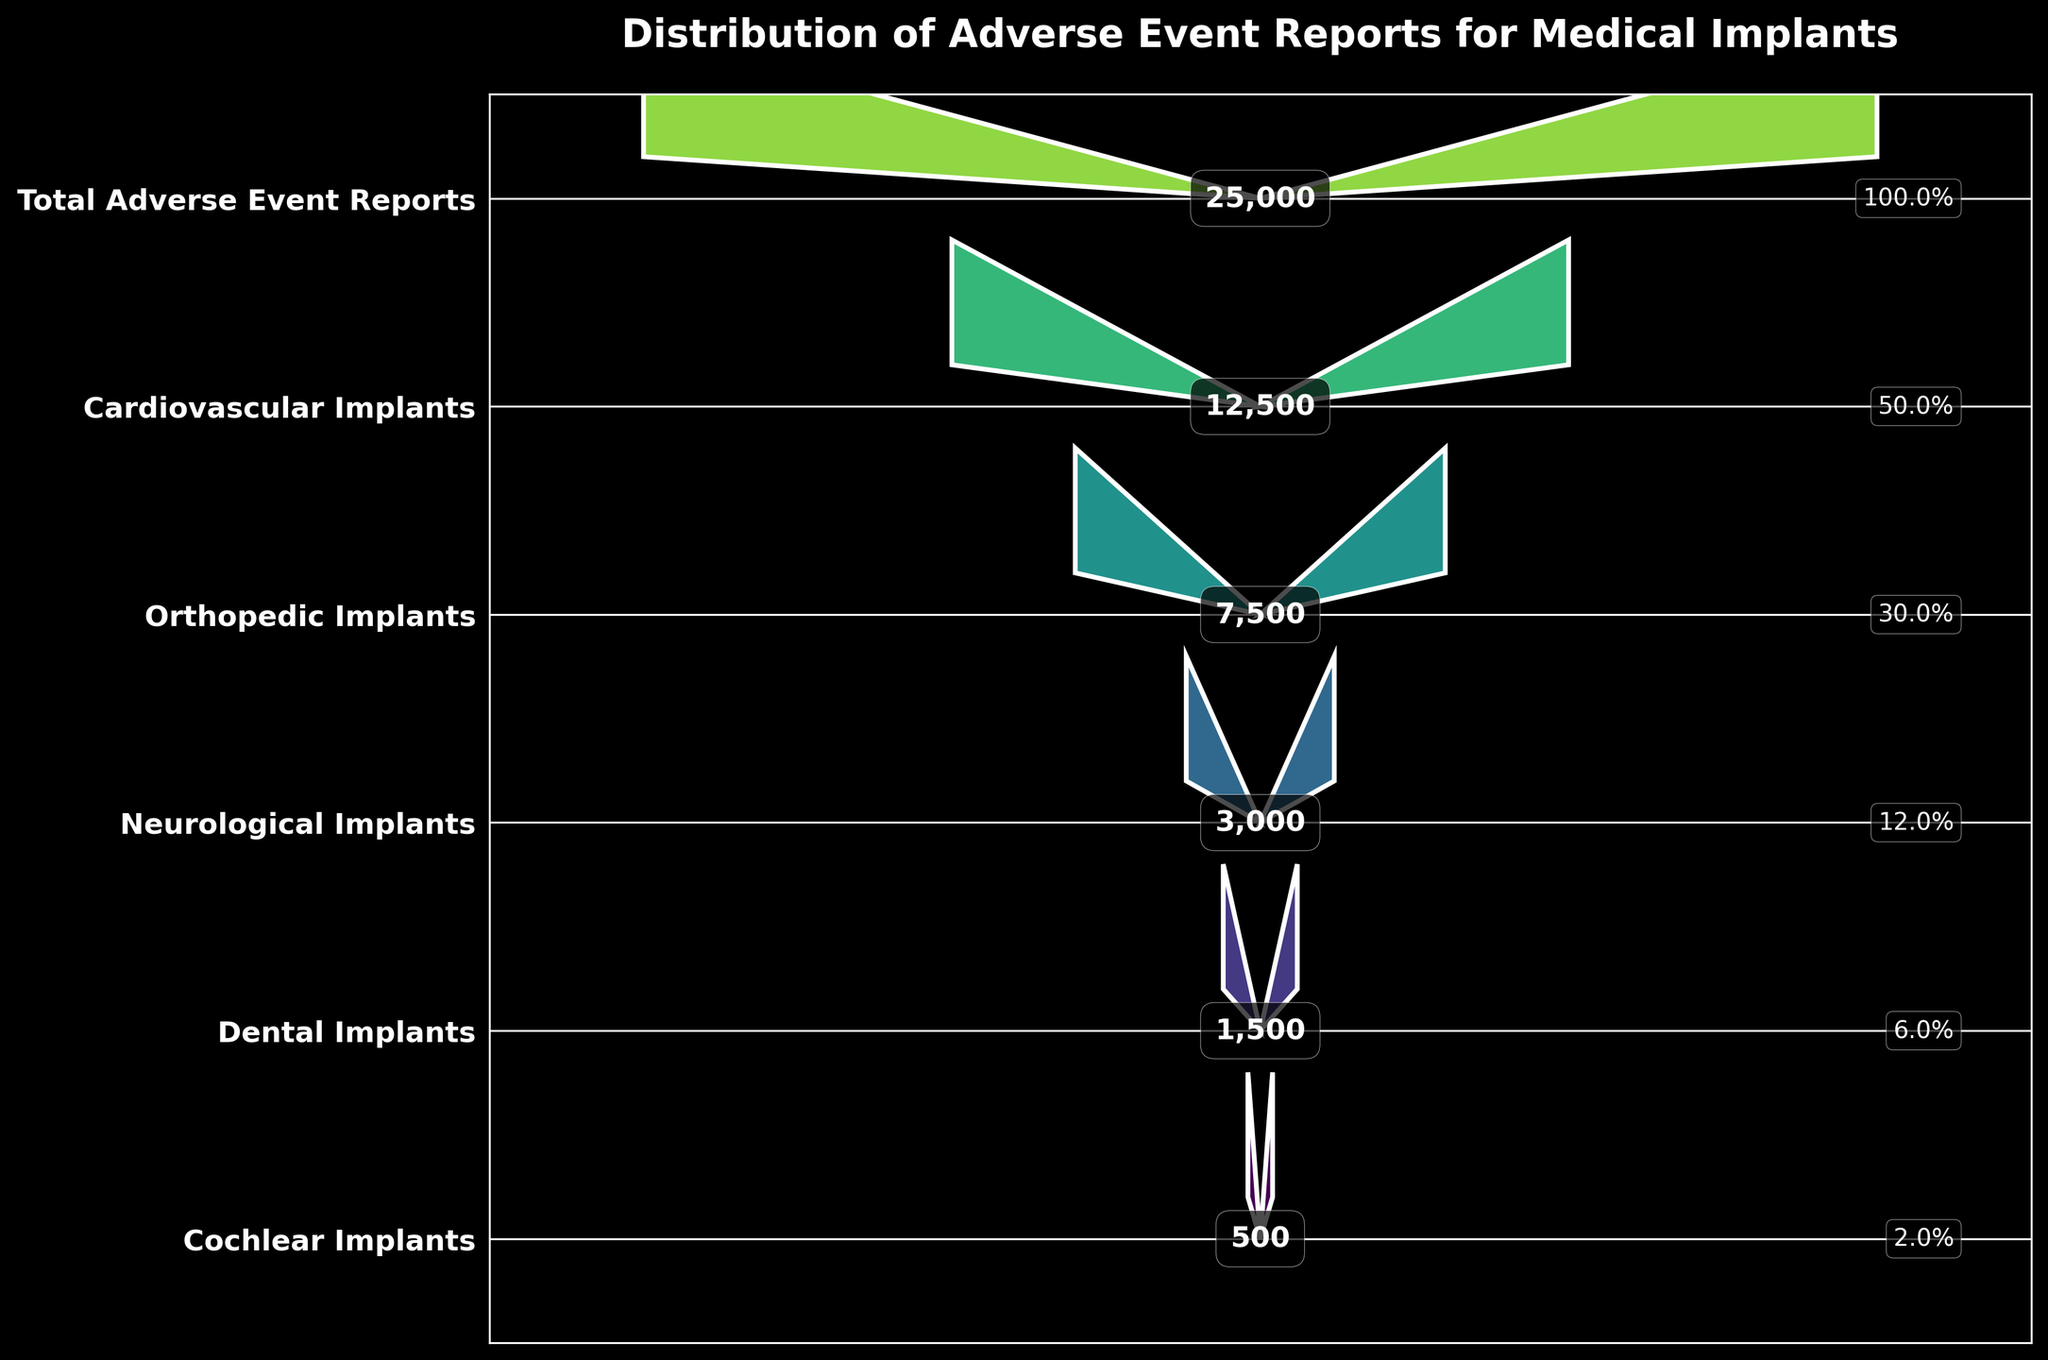What is the title of the funnel chart? The title of the funnel chart is displayed at the top of the figure. It clearly states the main topic of the visualization.
Answer: Distribution of Adverse Event Reports for Medical Implants How many categories are represented in the funnel chart? Count the number of distinct categories shown on the y-axis labels of the funnel chart.
Answer: 6 What percentage of the total adverse event reports corresponds to Neurological Implants? First, note the number of reports for Neurological Implants (3,000) and the total number of adverse event reports (25,000). Calculate the percentage: (3,000 / 25,000) * 100%.
Answer: 12% Which type of medical implant has the highest number of adverse event reports? Compare the numbers of adverse event reports for all the categories displayed in the figure. Identify the category with the highest value.
Answer: Cardiovascular Implants What is the difference in the number of adverse event reports between Orthopedic Implants and Dental Implants? Identify the number of reports for Orthopedic Implants (7,500) and Dental Implants (1,500). Subtract the smaller number from the larger one: 7,500 - 1,500.
Answer: 6,000 What is the proportion of Cochlear Implants reports to the total reports? Determine the number of reports for Cochlear Implants (500) and the total number of reports (25,000). Calculate the proportion: 500 / 25,000.
Answer: 0.02 Which categories have less than 10% of the total adverse event reports? Calculate 10% of the total adverse event reports (25,000), which is 2,500. Identify the categories with reports fewer than 2,500.
Answer: Dental Implants, Cochlear Implants What is the combined number of adverse event reports for Cardiovascular and Neurological Implants? Add the number of reports for Cardiovascular Implants (12,500) and Neurological Implants (3,000).
Answer: 15,500 How does the width of the funnel segment for Orthopedic Implants visually compare to that of Dental Implants? Observe the width of the funnel segments corresponding to Orthopedic Implants and Dental Implants. Determine if the Orthopedic Implants segment is wider, narrower, or equal in width compared to the Dental Implants segment.
Answer: Wider 